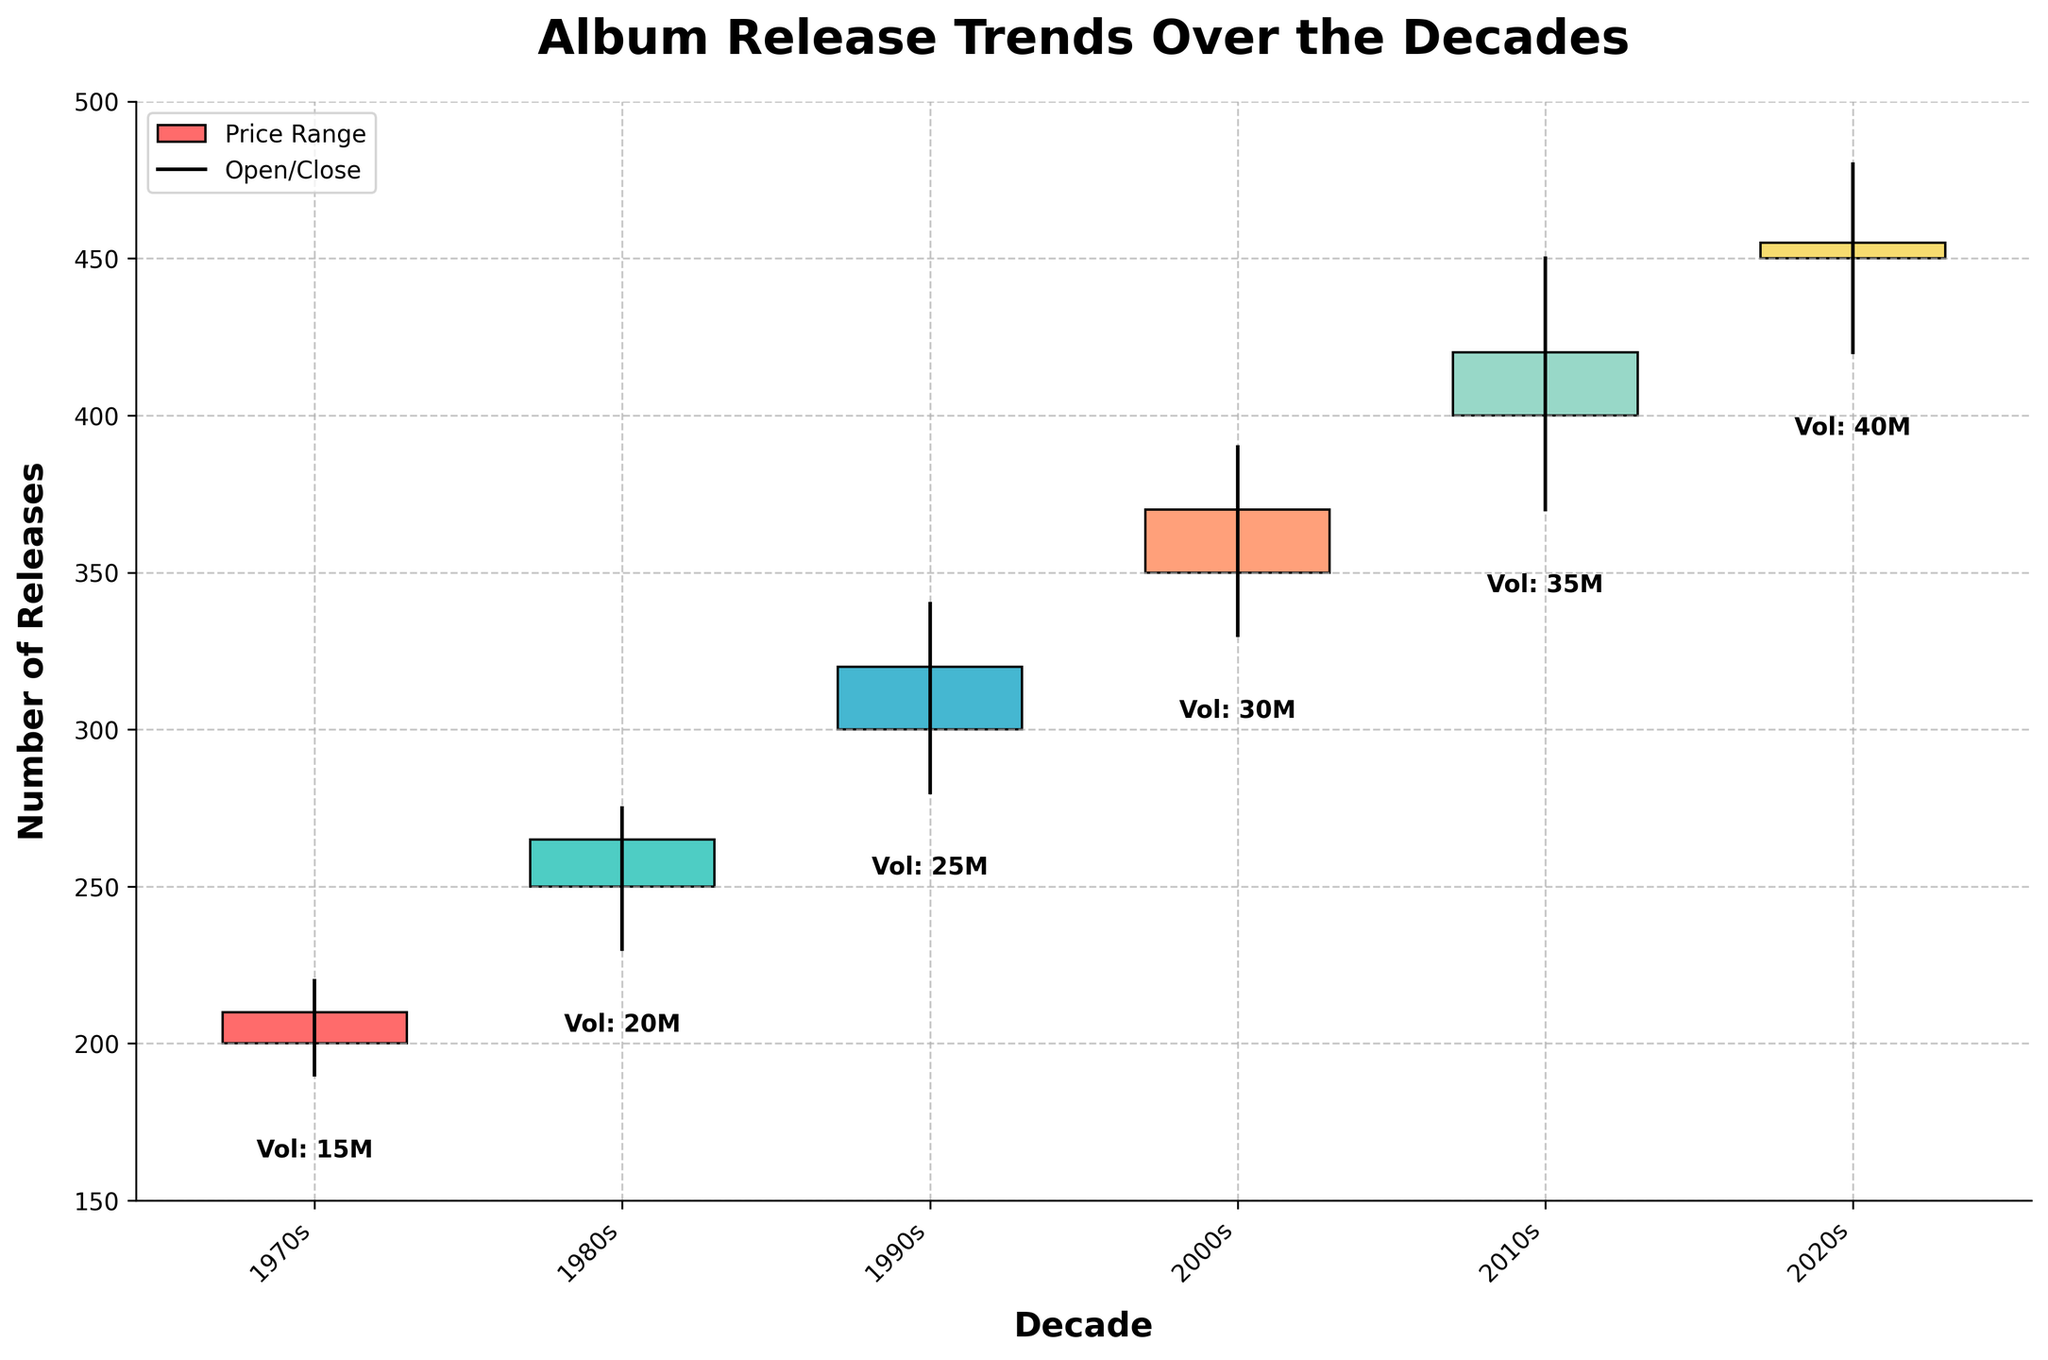what is the title of the plot? The plot’s title is located at the top and provides a summary of the figure's content. It is "Album Release Trends Over the Decades."
Answer: Album Release Trends Over the Decades what does the x-axis represent? The x-axis shows the categories being analyzed in the plot and represents the decades, from the 1970s to the 2020s.
Answer: Decades what information is displayed on the y-axis? The y-axis displays the number of releases, ranging from 150 to 500.
Answer: Number of Releases which decade saw the highest 'Close' value? The 'Close' value is signed as the top of the filled or empty rectangle depending on the closing value per decade. The 2020s have the highest 'Close' value at 455.
Answer: 2020s which decade experienced the lowest 'Low' value? The 'Low' value represents the bottom value of the thin vertical line below the rectangle. The 1970s experienced the lowest 'Low' value at 190.
Answer: 1970s how does the 'Volume' trend change over the decades? The volume is shown as text under each decade's data, representing the number of top-selling releases in millions. It increases progressively from 15M in the 1970s to 40M in the 2020s.
Answer: Increasing Trend what's the average 'High' value for all decades? To find the average, add the high values (220, 275, 340, 390, 450, 480) and divide by the number of decades (6). Sum = 2155. Average = 2155/6 ≈ 359.2
Answer: 359.2 compare the 'Open' and 'Close' values of the 1980s. The 'Open' value for the 1980s is 250, and the 'Close' value is 265. Since 265 is greater than 250, the 'Close' is higher than the 'Open.'
Answer: Close is higher which decade shows the widest range between 'Low' and 'High' values? Calculate the range for each decade by subtracting 'Low' from 'High'. The 2010s have the widest range: 450-370 = 80.
Answer: 2010s which decade has the smallest rise from 'Open' to 'Close' value? Subtract the 'Open' value from the 'Close' value for each decade. The decade with the smallest difference is the 1970s, with a rise of 210-200 = 10.
Answer: 1970s 